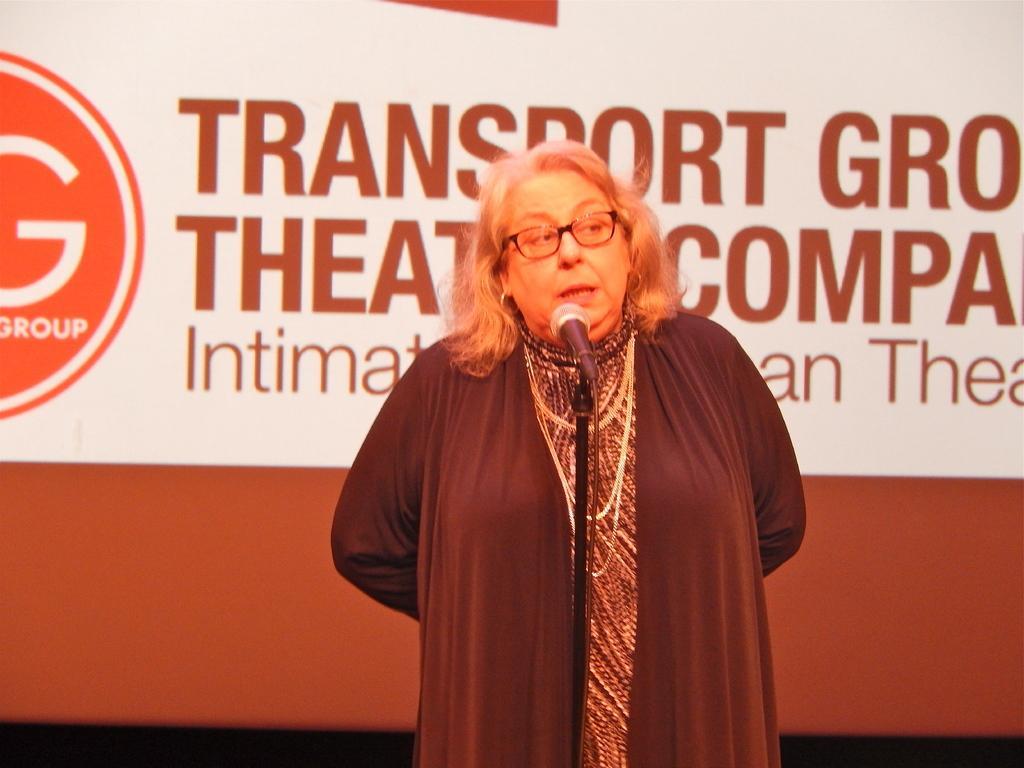How would you summarize this image in a sentence or two? In this picture we can see a woman is standing and speaking something, there is a microphone in front of her, in the background it looks like a screen, there is some text on the screen. 